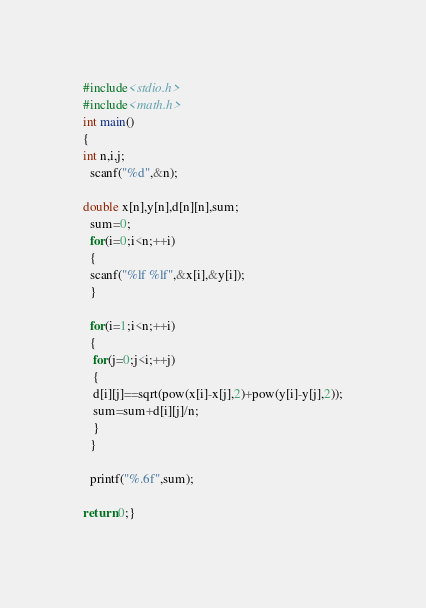Convert code to text. <code><loc_0><loc_0><loc_500><loc_500><_C_>#include<stdio.h>
#include<math.h>
int main()
{
int n,i,j;
  scanf("%d",&n);
  
double x[n],y[n],d[n][n],sum;
  sum=0;
  for(i=0;i<n;++i)
  {
  scanf("%lf %lf",&x[i],&y[i]);
  }
  
  for(i=1;i<n;++i)
  {
   for(j=0;j<i;++j)
   {
   d[i][j]==sqrt(pow(x[i]-x[j],2)+pow(y[i]-y[j],2));
   sum=sum+d[i][j]/n;
   }
  }

  printf("%.6f",sum);
  
return 0;}</code> 